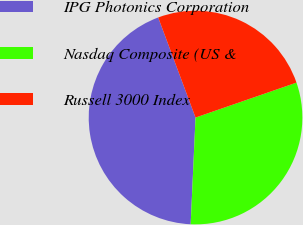Convert chart. <chart><loc_0><loc_0><loc_500><loc_500><pie_chart><fcel>IPG Photonics Corporation<fcel>Nasdaq Composite (US &<fcel>Russell 3000 Index<nl><fcel>43.6%<fcel>31.03%<fcel>25.38%<nl></chart> 